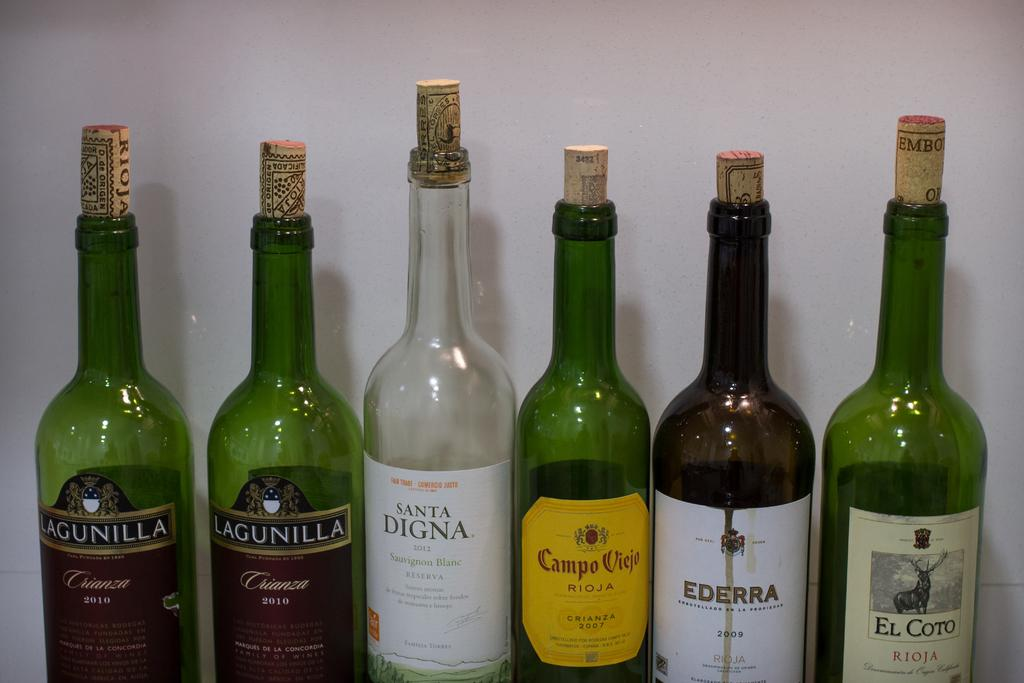Provide a one-sentence caption for the provided image. Six wine bottle with one of them named Santa Digna. 